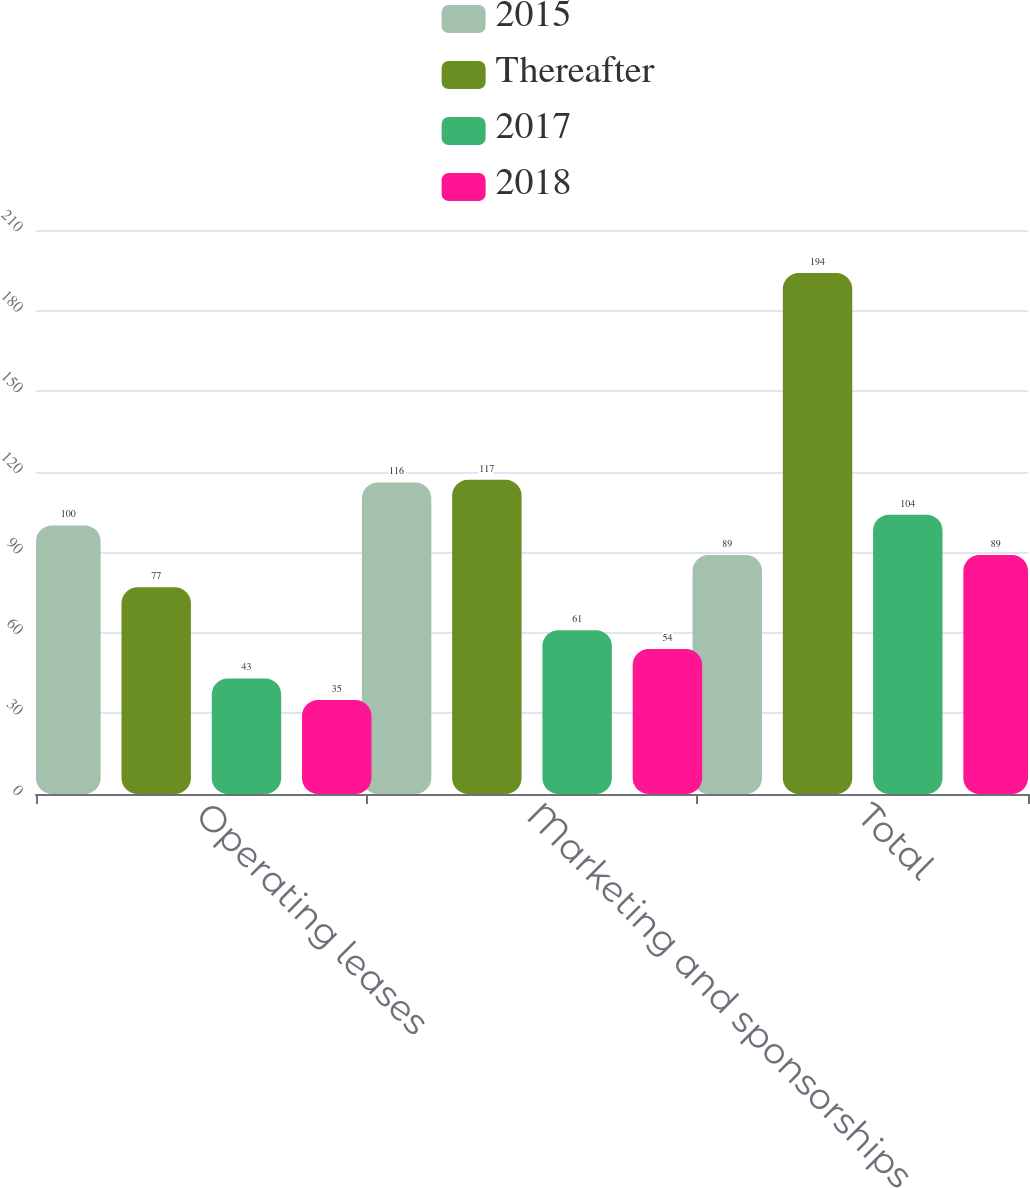Convert chart to OTSL. <chart><loc_0><loc_0><loc_500><loc_500><stacked_bar_chart><ecel><fcel>Operating leases<fcel>Marketing and sponsorships<fcel>Total<nl><fcel>2015<fcel>100<fcel>116<fcel>89<nl><fcel>Thereafter<fcel>77<fcel>117<fcel>194<nl><fcel>2017<fcel>43<fcel>61<fcel>104<nl><fcel>2018<fcel>35<fcel>54<fcel>89<nl></chart> 